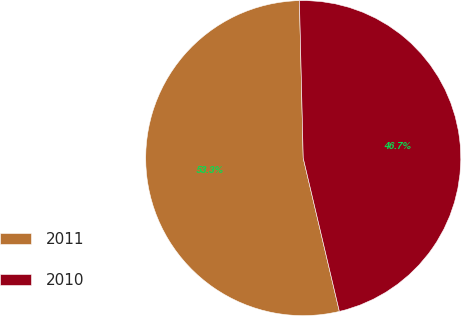Convert chart. <chart><loc_0><loc_0><loc_500><loc_500><pie_chart><fcel>2011<fcel>2010<nl><fcel>53.3%<fcel>46.7%<nl></chart> 